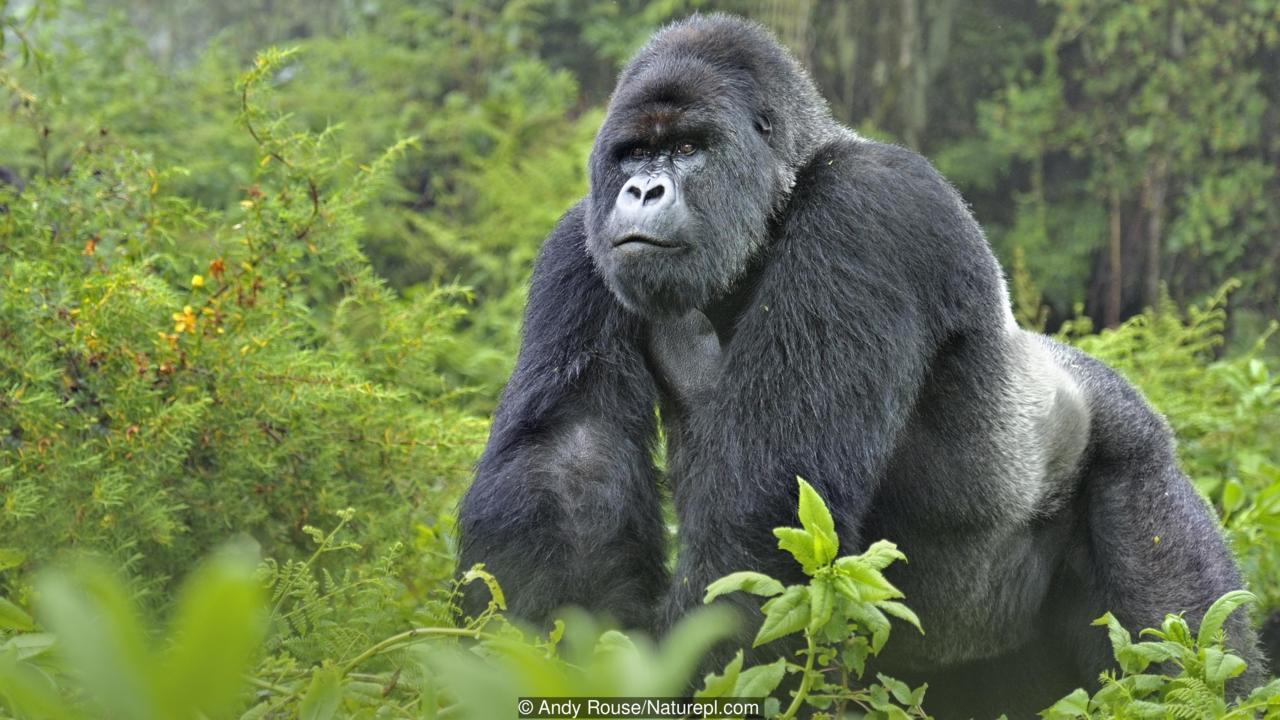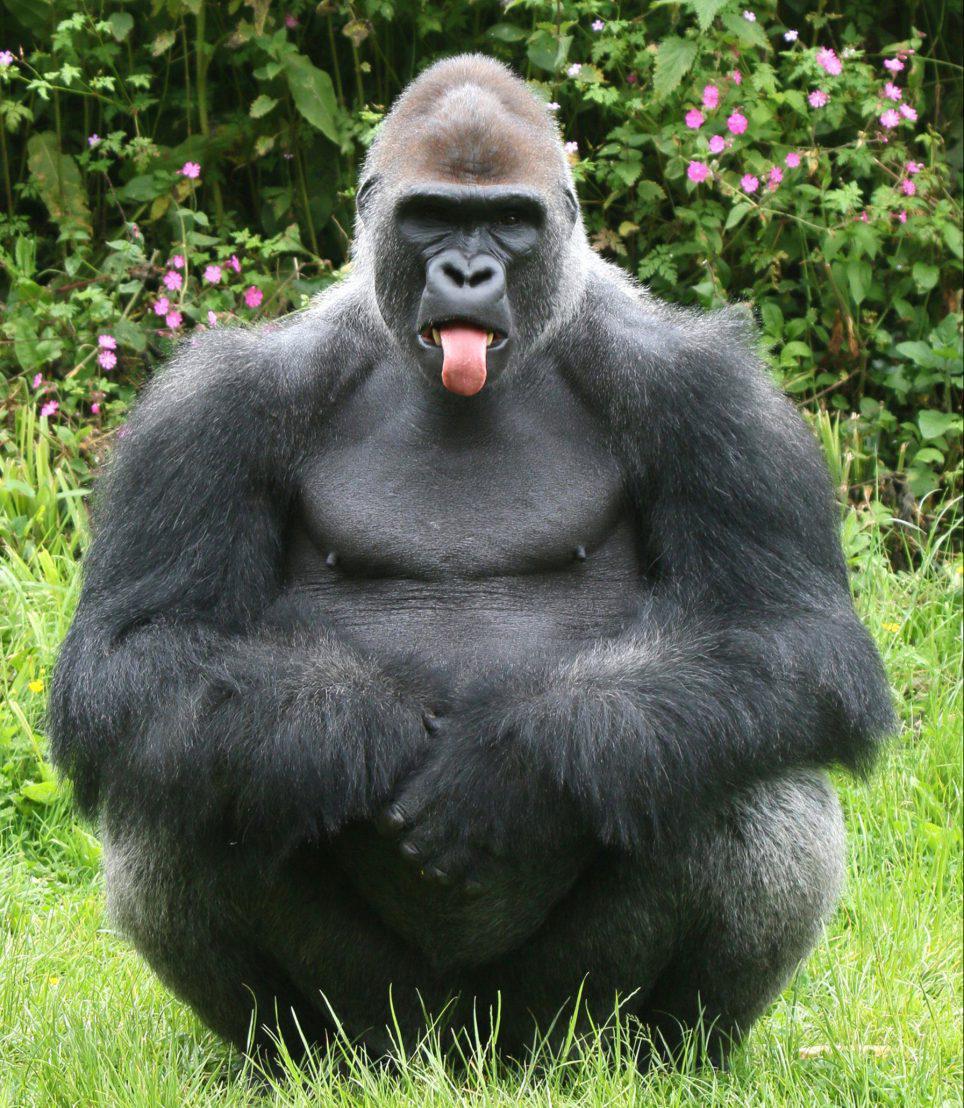The first image is the image on the left, the second image is the image on the right. Examine the images to the left and right. Is the description "There is exactly one animal in the image on the left." accurate? Answer yes or no. Yes. The first image is the image on the left, the second image is the image on the right. Given the left and right images, does the statement "An image shows three gorillas of different sizes." hold true? Answer yes or no. No. 